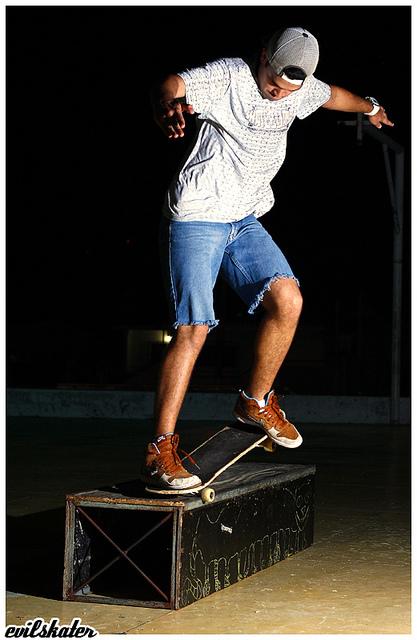Are all four wheels in the air?
Keep it brief. No. How have this man's pants been altered?
Answer briefly. Cut off. Is his cap on backwards?
Concise answer only. Yes. 